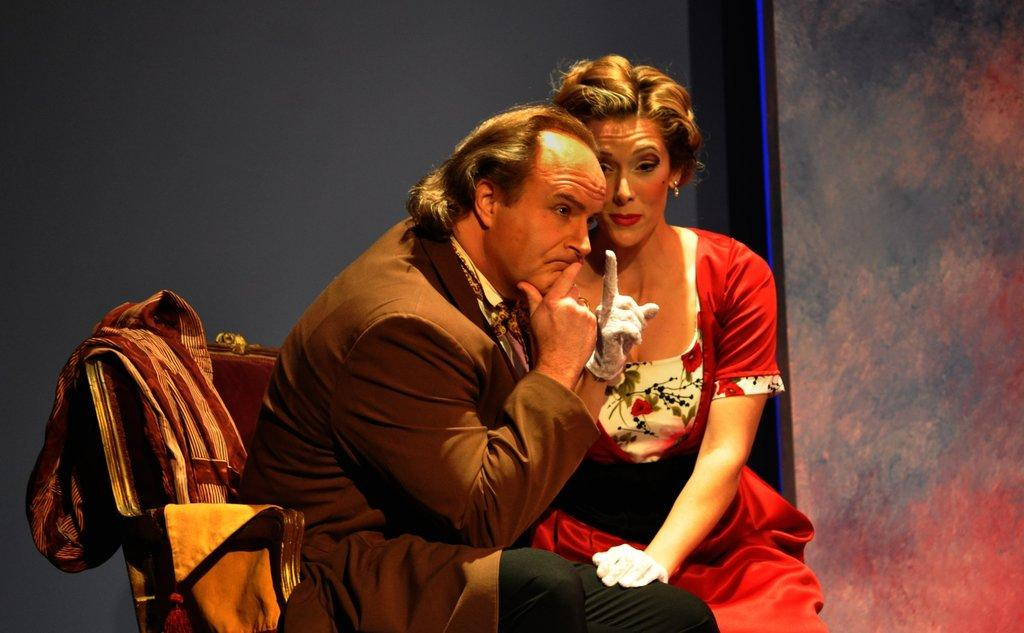How many people are sitting on the chair in the image? There are two people sitting on the chair in the image. What is placed on top of the chair? A shawl is present on top of the chair. Can you describe the interaction between the two people on the chair? A woman is touching a man's leg. What type of insect can be seen crawling on the shawl in the image? There are no insects present in the image; only the two people and the shawl can be seen. 